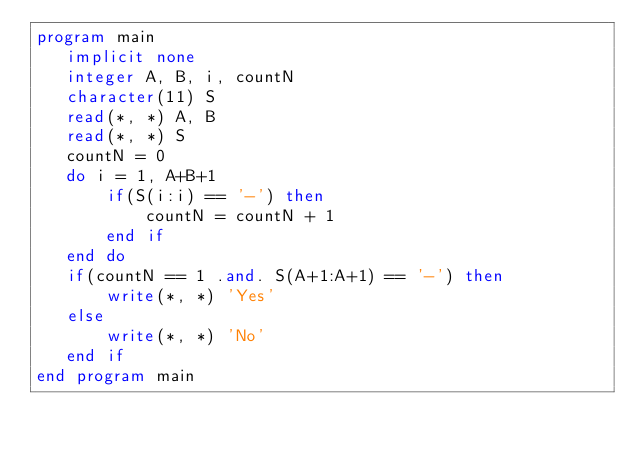<code> <loc_0><loc_0><loc_500><loc_500><_FORTRAN_>program main
   implicit none
   integer A, B, i, countN
   character(11) S
   read(*, *) A, B
   read(*, *) S
   countN = 0
   do i = 1, A+B+1
       if(S(i:i) == '-') then
           countN = countN + 1
       end if
   end do
   if(countN == 1 .and. S(A+1:A+1) == '-') then
       write(*, *) 'Yes'
   else
       write(*, *) 'No'
   end if
end program main</code> 